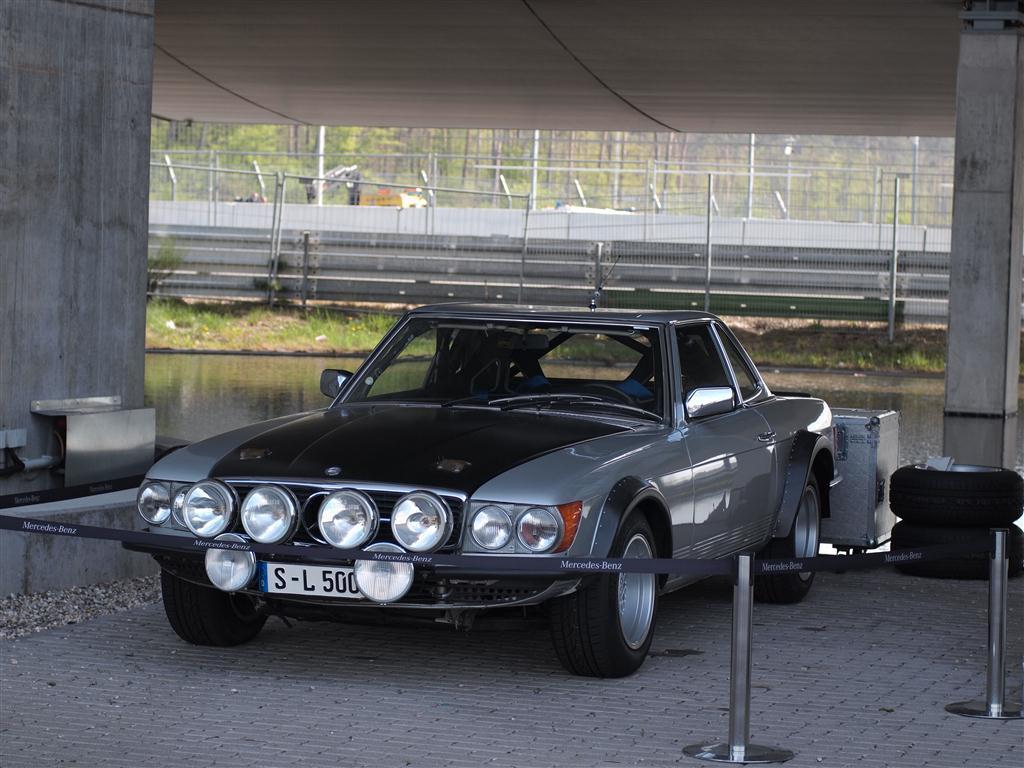Describe this image in one or two sentences. In the picture there is a vehicle kept under a shelter and beside the vehicle there are two tyres, in the background there is a lake and behind the lake there is a mesh. 